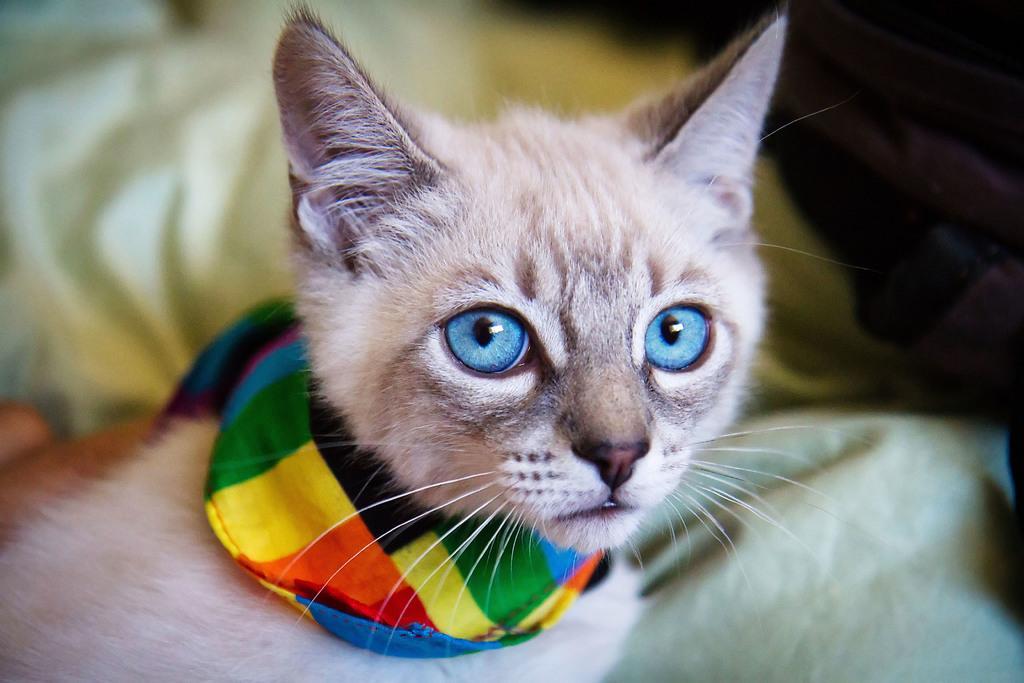In one or two sentences, can you explain what this image depicts? In this image we can see one cat, colorful kerchief around the cat's neck and some objects on the surface. 